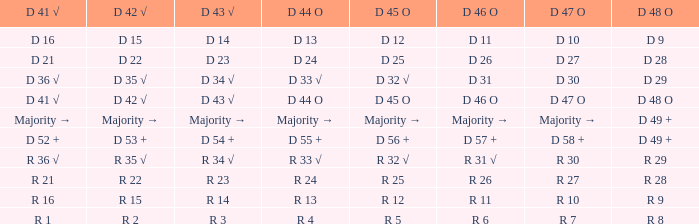Identify the d 45 o with d 46 o of r 31 √ R 32 √. 